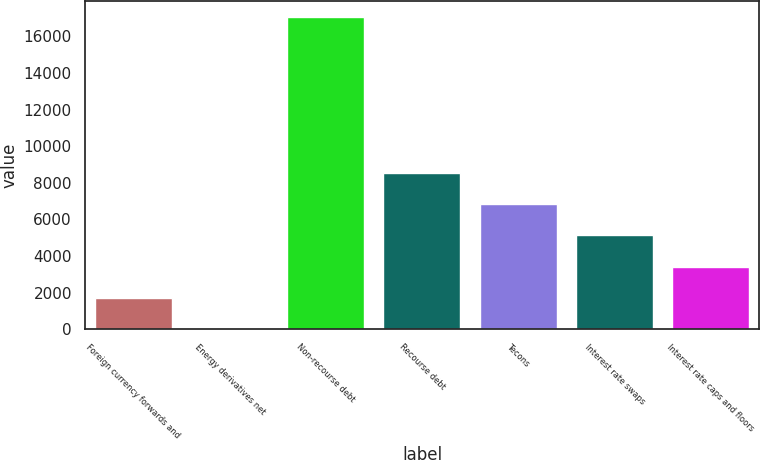Convert chart. <chart><loc_0><loc_0><loc_500><loc_500><bar_chart><fcel>Foreign currency forwards and<fcel>Energy derivatives net<fcel>Non-recourse debt<fcel>Recourse debt<fcel>Tecons<fcel>Interest rate swaps<fcel>Interest rate caps and floors<nl><fcel>1712.7<fcel>7<fcel>17064<fcel>8535.5<fcel>6829.8<fcel>5124.1<fcel>3418.4<nl></chart> 